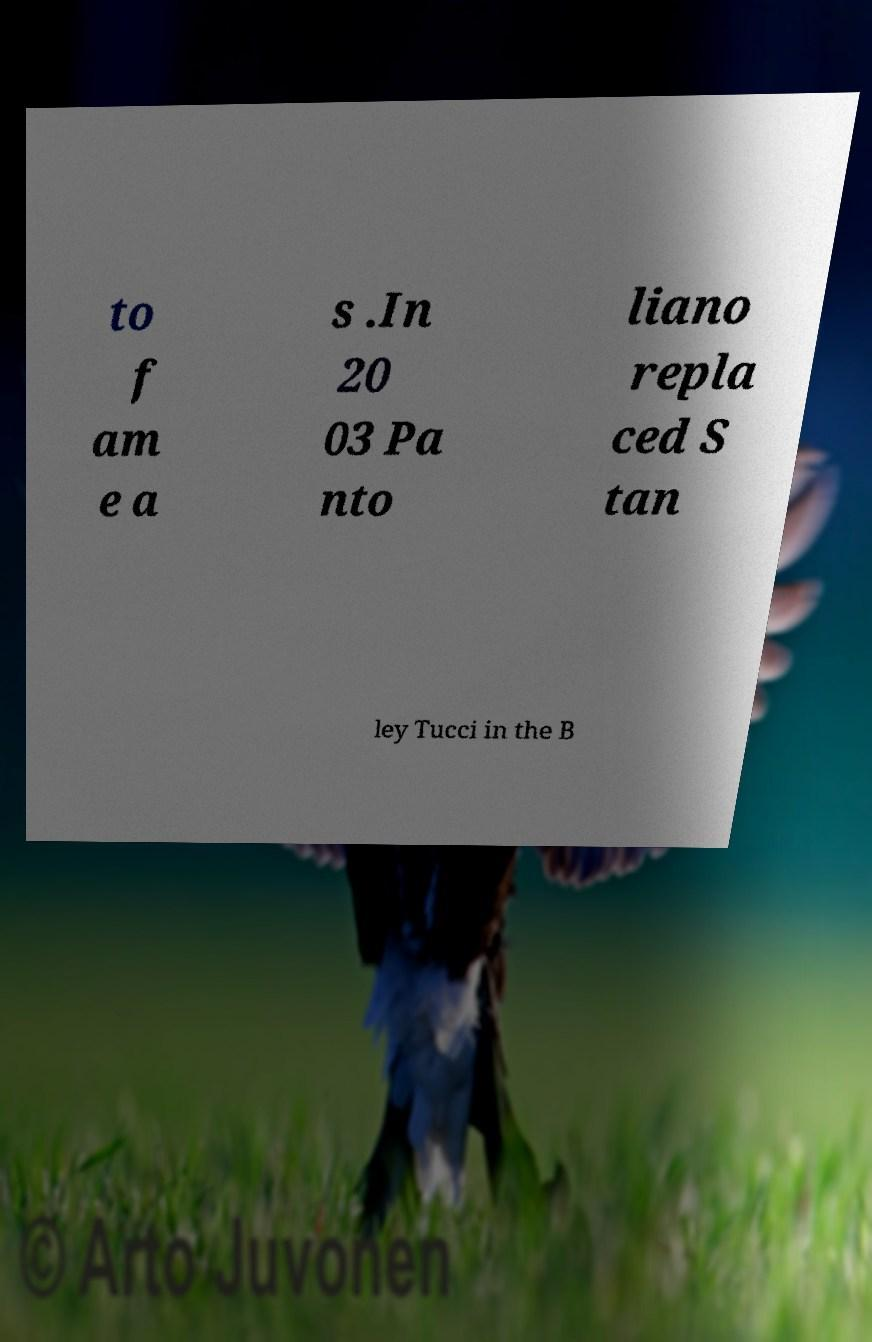There's text embedded in this image that I need extracted. Can you transcribe it verbatim? to f am e a s .In 20 03 Pa nto liano repla ced S tan ley Tucci in the B 